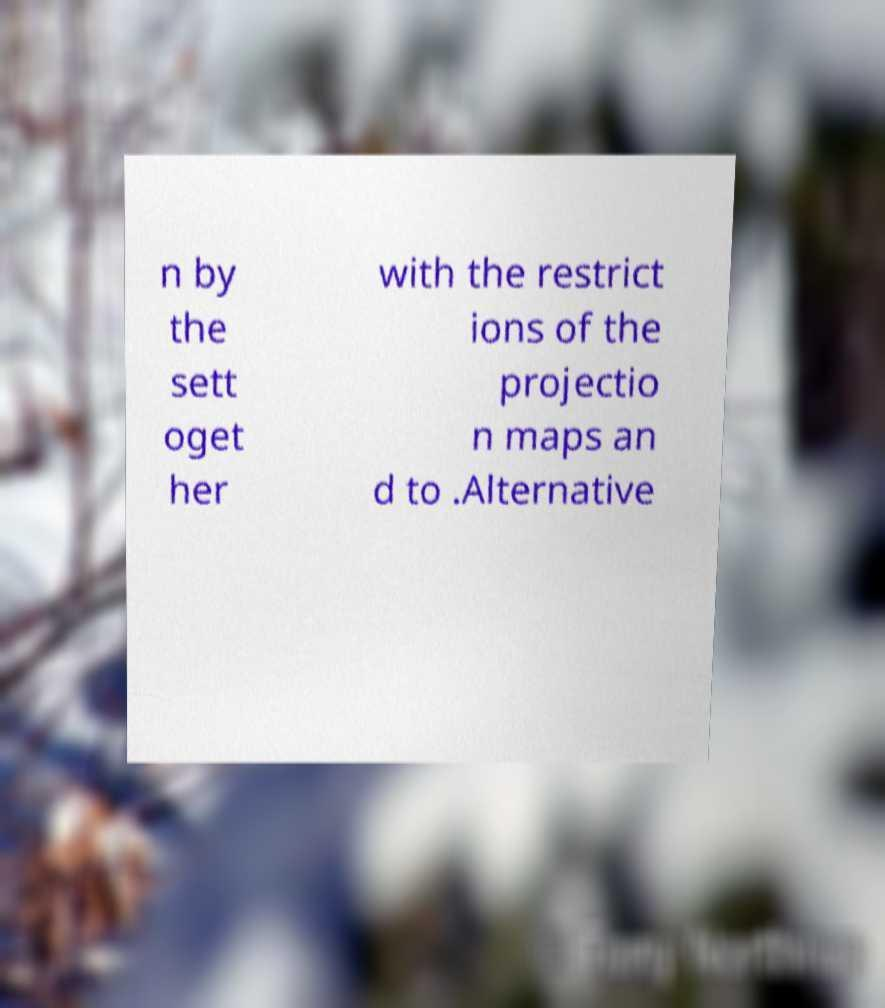Please identify and transcribe the text found in this image. n by the sett oget her with the restrict ions of the projectio n maps an d to .Alternative 